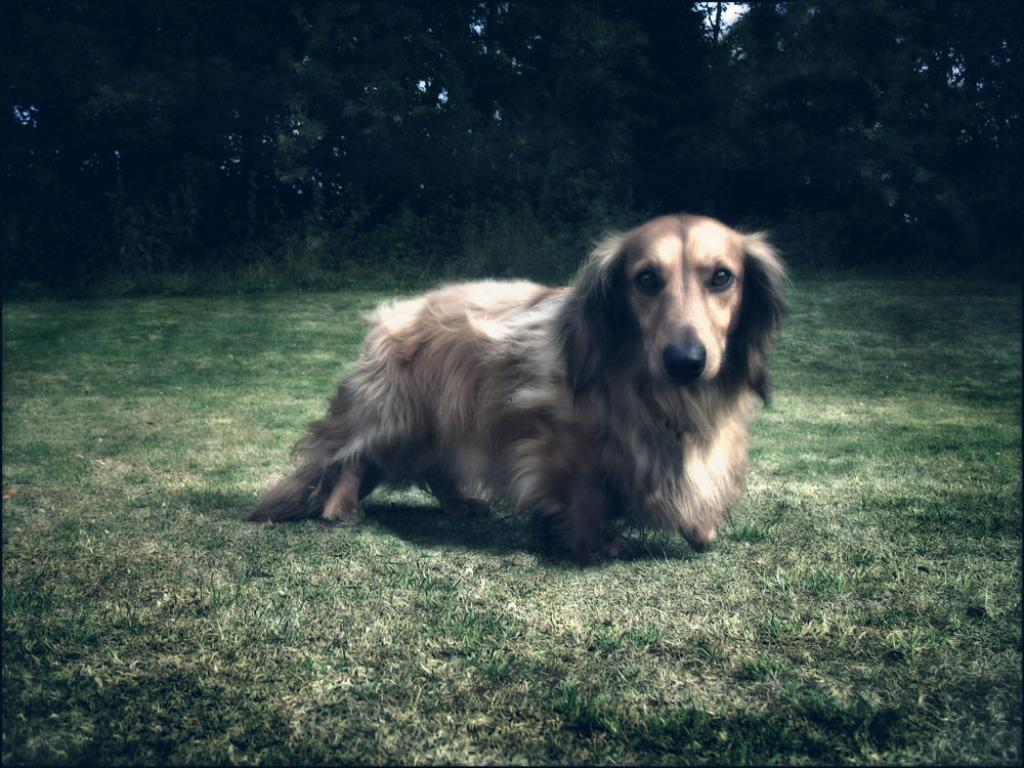What animal is present in the image? There is a dog in the image. Where is the dog located? The dog is on a grassland. What can be seen in the background of the image? There are trees in the background of the image. What type of cherries is the dog eating in the image? There are no cherries present in the image, and the dog is not eating anything. 